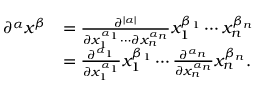Convert formula to latex. <formula><loc_0><loc_0><loc_500><loc_500>{ \begin{array} { r l } { \partial ^ { \alpha } x ^ { \beta } } & { = { \frac { \partial ^ { | \alpha | } } { \partial x _ { 1 } ^ { \alpha _ { 1 } } \cdots \partial x _ { n } ^ { \alpha _ { n } } } } x _ { 1 } ^ { \beta _ { 1 } } \cdots x _ { n } ^ { \beta _ { n } } } \\ & { = { \frac { \partial ^ { \alpha _ { 1 } } } { \partial x _ { 1 } ^ { \alpha _ { 1 } } } } x _ { 1 } ^ { \beta _ { 1 } } \cdots { \frac { \partial ^ { \alpha _ { n } } } { \partial x _ { n } ^ { \alpha _ { n } } } } x _ { n } ^ { \beta _ { n } } . } \end{array} }</formula> 